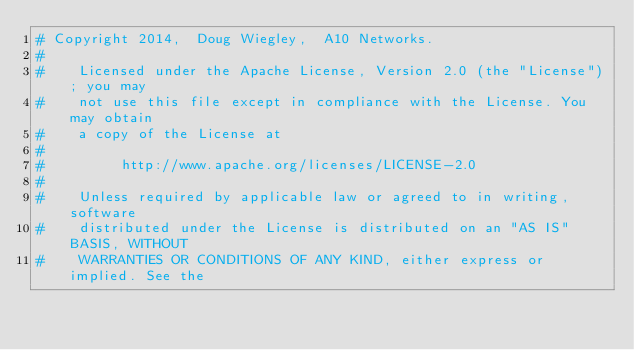<code> <loc_0><loc_0><loc_500><loc_500><_Python_># Copyright 2014,  Doug Wiegley,  A10 Networks.
#
#    Licensed under the Apache License, Version 2.0 (the "License"); you may
#    not use this file except in compliance with the License. You may obtain
#    a copy of the License at
#
#         http://www.apache.org/licenses/LICENSE-2.0
#
#    Unless required by applicable law or agreed to in writing, software
#    distributed under the License is distributed on an "AS IS" BASIS, WITHOUT
#    WARRANTIES OR CONDITIONS OF ANY KIND, either express or implied. See the</code> 